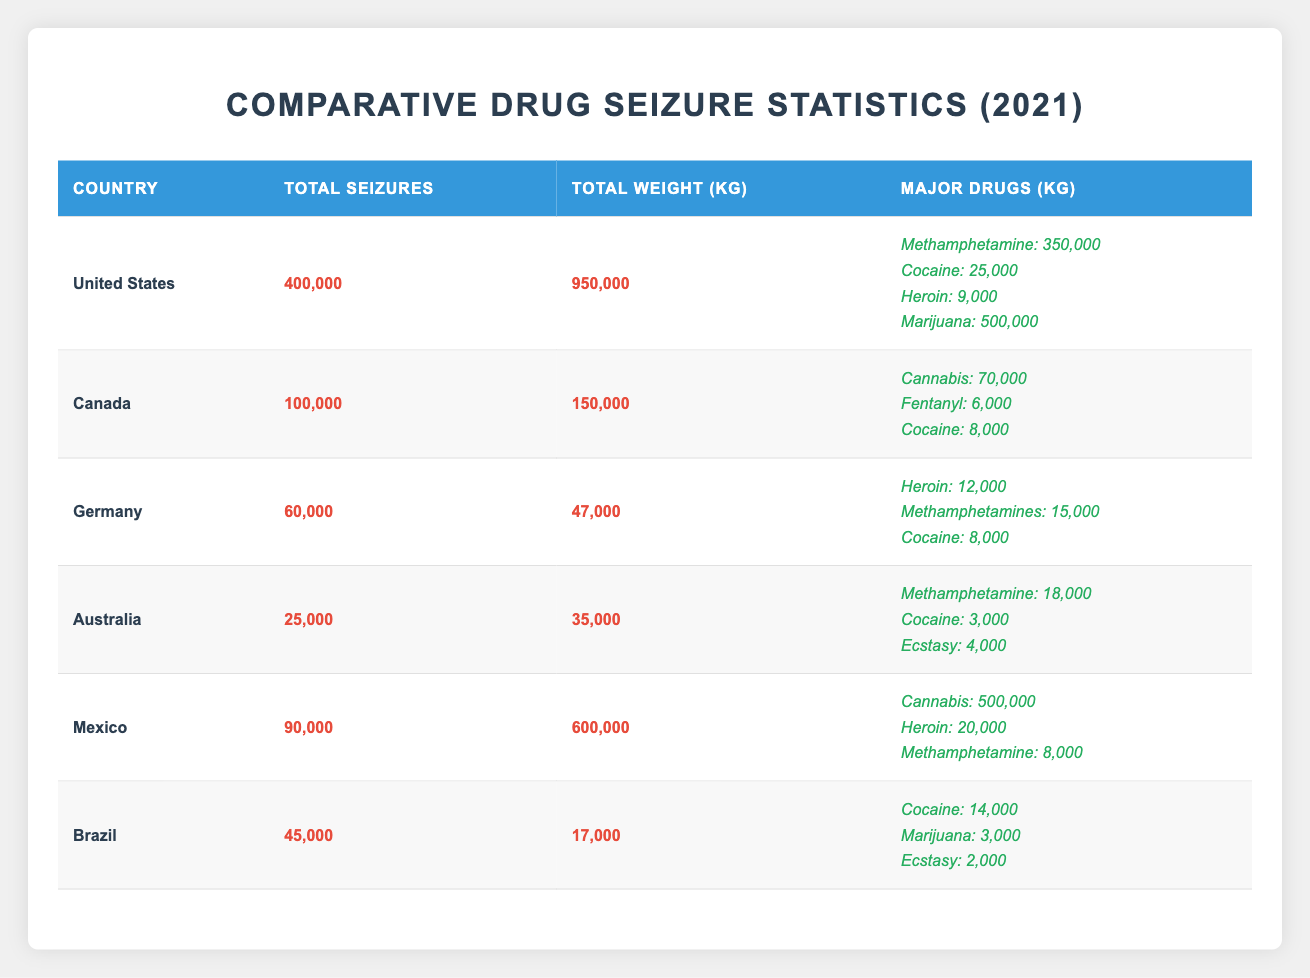What country had the highest total seizures? The table indicates that the United States had the highest total seizures at 400,000, which is greater than any other country listed.
Answer: United States How much cocaine was seized in Mexico? The table shows that Mexico seized 20,000 kg of cocaine in 2021, which is specified under the major drugs section for Mexico.
Answer: 20,000 kg What is the total weight of drug seizures in Australia and Germany combined? Adding the total weights from the two countries, Australia had 35,000 kg and Germany had 47,000 kg. The total is 35,000 + 47,000 = 82,000 kg.
Answer: 82,000 kg Did Canada seize more cannabis than Germany seized heroin? According to the table, Canada seized 70,000 kg of cannabis while Germany seized 12,000 kg of heroin. Since 70,000 is greater than 12,000, the answer is yes.
Answer: Yes What country had the least total seizures, and how many were there? Referring to the table, Australia had the least total seizures with 25,000. This is lower than any other country’s total listed.
Answer: Australia, 25,000 Which drug had the highest total weight seized in the United States? Under the major drugs listed for the United States, Methamphetamine had the highest weight seized at 350,000 kg, making it the most significant drug by weight.
Answer: Methamphetamine, 350,000 kg What percentage of total seizures in the United States were of marijuana? The total seizures in the United States were 400,000, and the weight of marijuana seized was 500,000 kg; hence, the percentage is calculated by (500,000 / 400,000) * 100 which equals 125%.
Answer: 125% How much more total weight was seized in Mexico compared to Canada? The total weights for Mexico and Canada are 600,000 kg and 150,000 kg, respectively. The difference is calculated by 600,000 - 150,000 = 450,000 kg.
Answer: 450,000 kg What major drug was seized the most in Canada? According to the table, the most seized drug in Canada was Cannabis at 70,000 kg, which is greater than the weights of other drugs listed.
Answer: Cannabis, 70,000 kg 